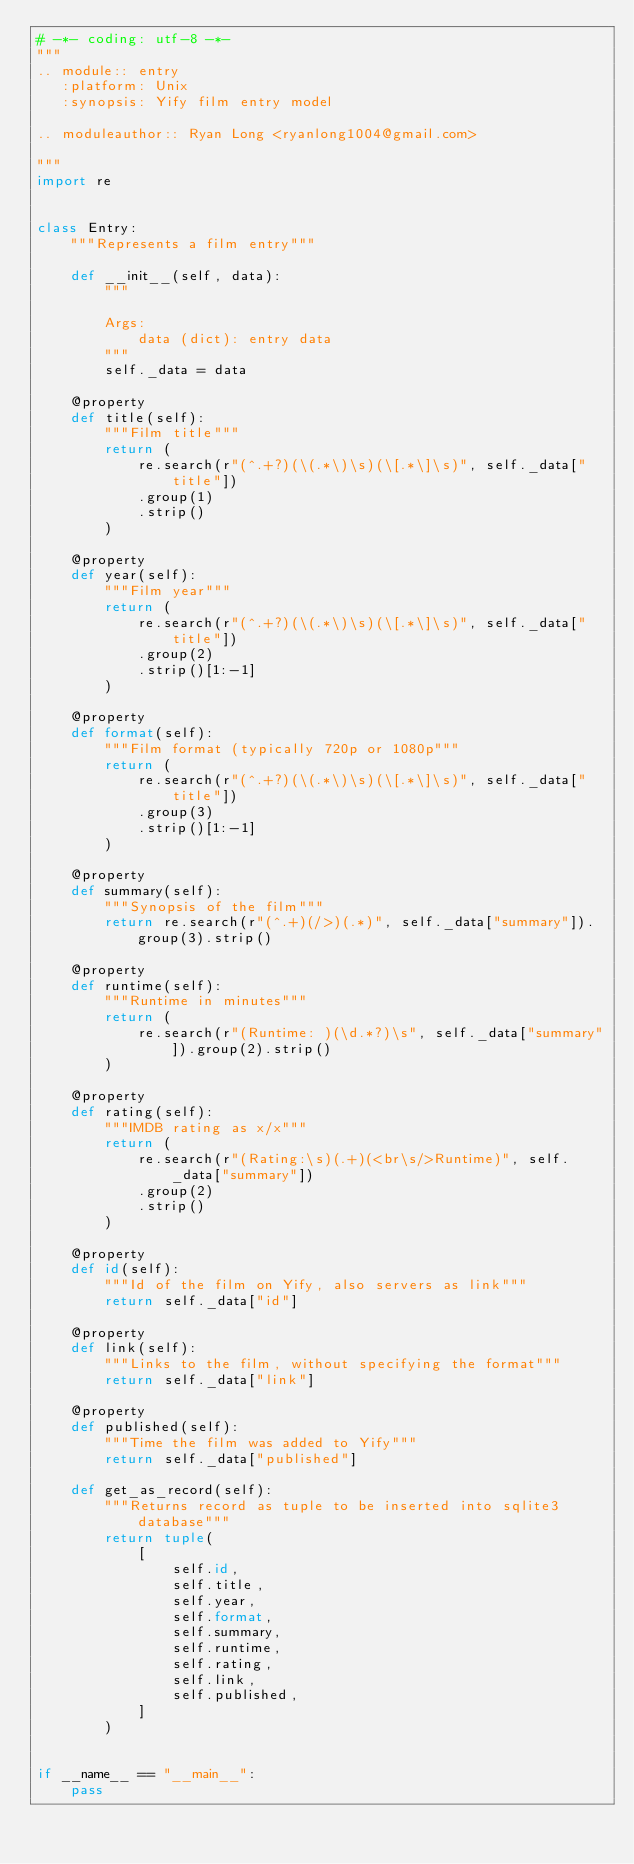Convert code to text. <code><loc_0><loc_0><loc_500><loc_500><_Python_># -*- coding: utf-8 -*-
"""
.. module:: entry
   :platform: Unix
   :synopsis: Yify film entry model

.. moduleauthor:: Ryan Long <ryanlong1004@gmail.com>

"""
import re


class Entry:
    """Represents a film entry"""

    def __init__(self, data):
        """

        Args:
            data (dict): entry data
        """
        self._data = data

    @property
    def title(self):
        """Film title"""
        return (
            re.search(r"(^.+?)(\(.*\)\s)(\[.*\]\s)", self._data["title"])
            .group(1)
            .strip()
        )

    @property
    def year(self):
        """Film year"""
        return (
            re.search(r"(^.+?)(\(.*\)\s)(\[.*\]\s)", self._data["title"])
            .group(2)
            .strip()[1:-1]
        )

    @property
    def format(self):
        """Film format (typically 720p or 1080p"""
        return (
            re.search(r"(^.+?)(\(.*\)\s)(\[.*\]\s)", self._data["title"])
            .group(3)
            .strip()[1:-1]
        )

    @property
    def summary(self):
        """Synopsis of the film"""
        return re.search(r"(^.+)(/>)(.*)", self._data["summary"]).group(3).strip()

    @property
    def runtime(self):
        """Runtime in minutes"""
        return (
            re.search(r"(Runtime: )(\d.*?)\s", self._data["summary"]).group(2).strip()
        )

    @property
    def rating(self):
        """IMDB rating as x/x"""
        return (
            re.search(r"(Rating:\s)(.+)(<br\s/>Runtime)", self._data["summary"])
            .group(2)
            .strip()
        )

    @property
    def id(self):
        """Id of the film on Yify, also servers as link"""
        return self._data["id"]

    @property
    def link(self):
        """Links to the film, without specifying the format"""
        return self._data["link"]

    @property
    def published(self):
        """Time the film was added to Yify"""
        return self._data["published"]

    def get_as_record(self):
        """Returns record as tuple to be inserted into sqlite3 database"""
        return tuple(
            [
                self.id,
                self.title,
                self.year,
                self.format,
                self.summary,
                self.runtime,
                self.rating,
                self.link,
                self.published,
            ]
        )


if __name__ == "__main__":
    pass
</code> 